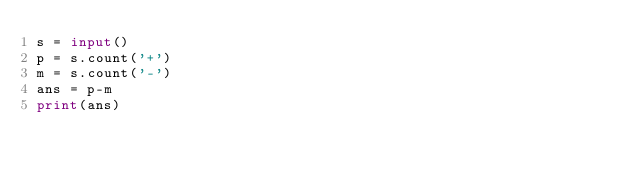<code> <loc_0><loc_0><loc_500><loc_500><_Python_>s = input()
p = s.count('+')
m = s.count('-')
ans = p-m
print(ans)</code> 